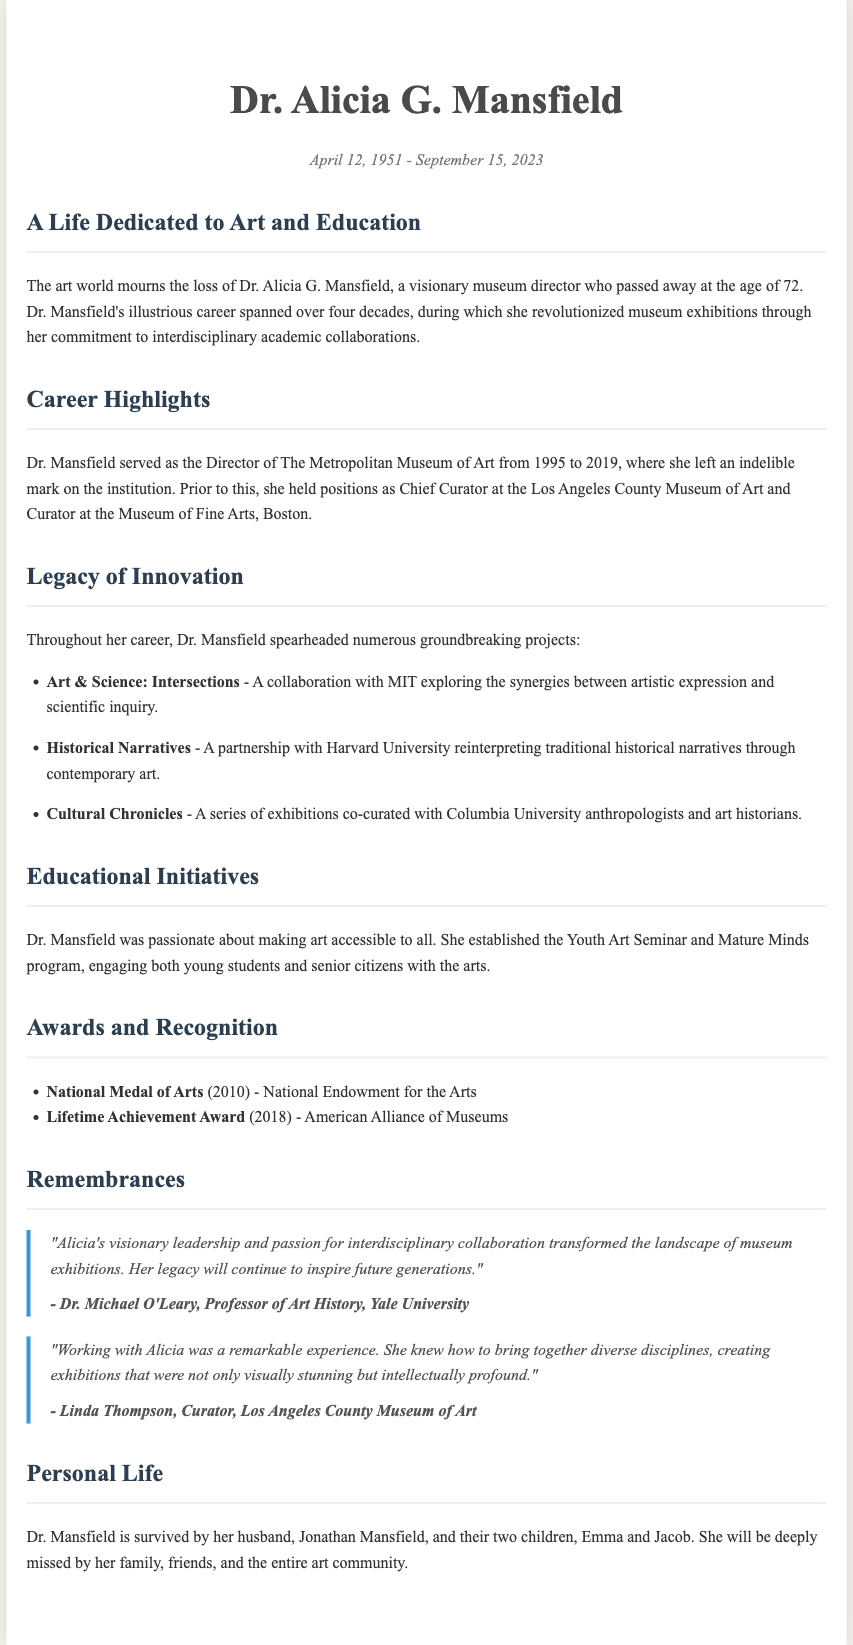What is Dr. Alicia G. Mansfield's birth date? The document states that Dr. Alicia G. Mansfield was born on April 12, 1951.
Answer: April 12, 1951 What was Dr. Mansfield's role from 1995 to 2019? According to the document, Dr. Mansfield served as the Director of The Metropolitan Museum of Art during this period.
Answer: Director of The Metropolitan Museum of Art Which award did she receive in 2010? The text mentions that she received the National Medal of Arts from the National Endowment for the Arts in 2010.
Answer: National Medal of Arts What was a significant project she collaborated on with MIT? The document notes the project "Art & Science: Intersections" as a collaboration with MIT.
Answer: Art & Science: Intersections How many children did Dr. Mansfield have? The document states that she is survived by two children, Emma and Jacob.
Answer: Two 